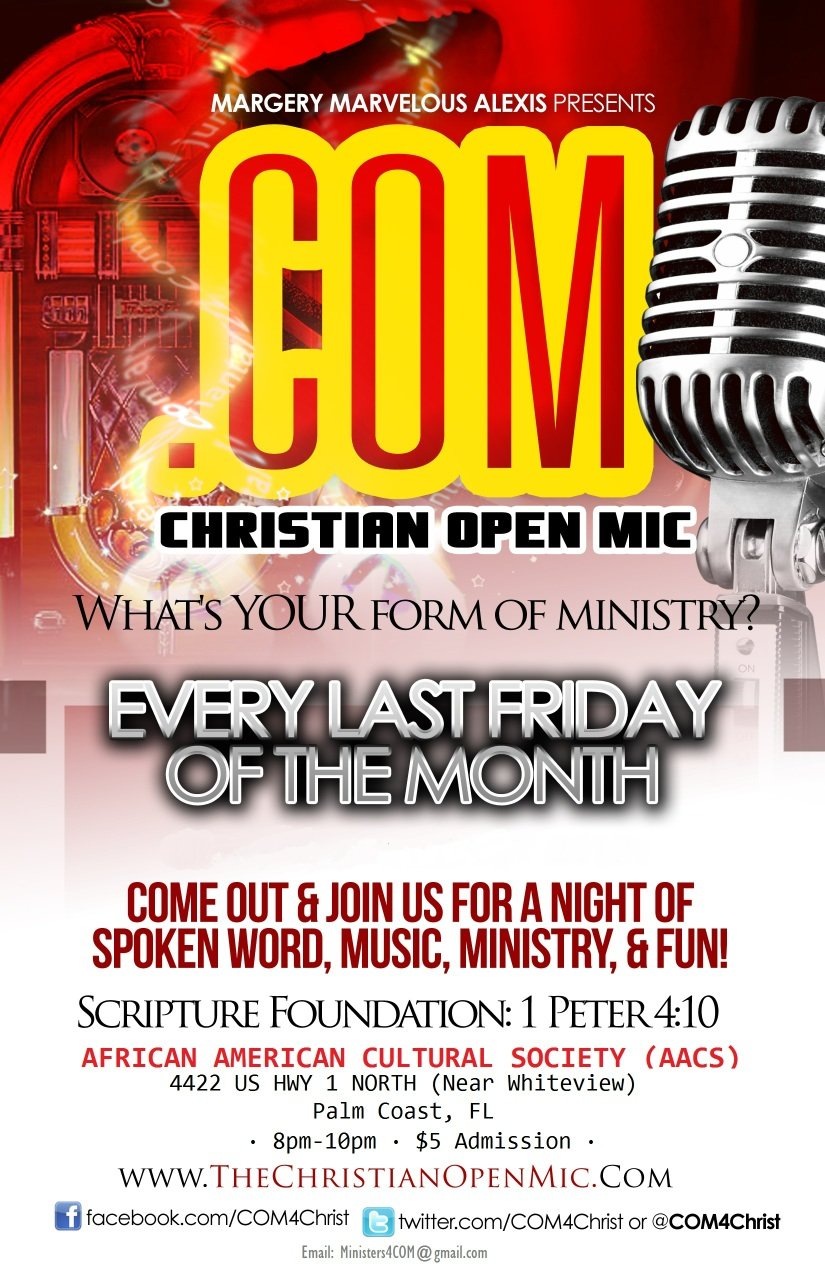Can you tell me more about the venue where the Christian Open Mic is held? The venue for the Christian Open Mic event is the African American Cultural Society (AACS) located at 4422 US Highway 1 North, near Whiteview in Palm Coast, Florida. This cultural hub is known for its vibrant celebration of African American heritage. It regularly hosts a variety of events focused on the arts, community engagement, and cultural expression. The AACS provides a welcoming space for community members to gather and share in cultural enrichment, and it plays a significant role in fostering unity and cultural awareness within the region. The Christian Open Mic, held every last Friday of the month, is a testament to this venue’s commitment to diversity and community spirit. 